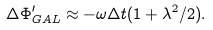<formula> <loc_0><loc_0><loc_500><loc_500>\Delta \Phi _ { G A L } ^ { \prime } \approx - \omega \Delta t ( 1 + \lambda ^ { 2 } / 2 ) .</formula> 